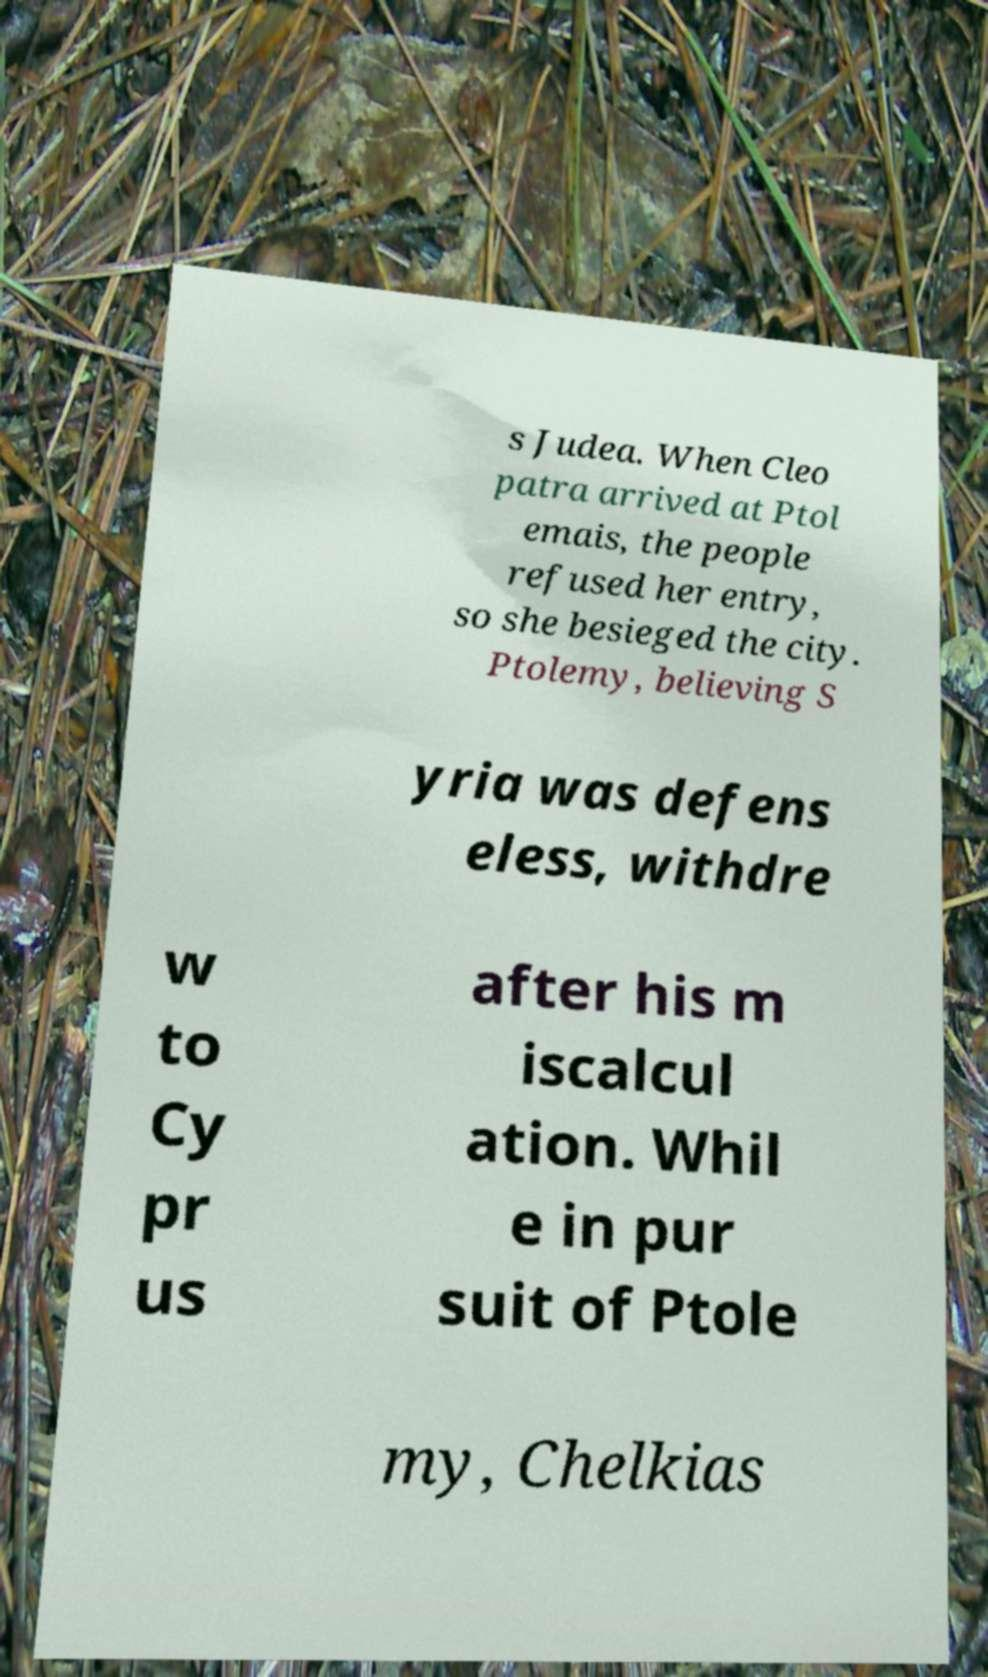Can you read and provide the text displayed in the image?This photo seems to have some interesting text. Can you extract and type it out for me? s Judea. When Cleo patra arrived at Ptol emais, the people refused her entry, so she besieged the city. Ptolemy, believing S yria was defens eless, withdre w to Cy pr us after his m iscalcul ation. Whil e in pur suit of Ptole my, Chelkias 